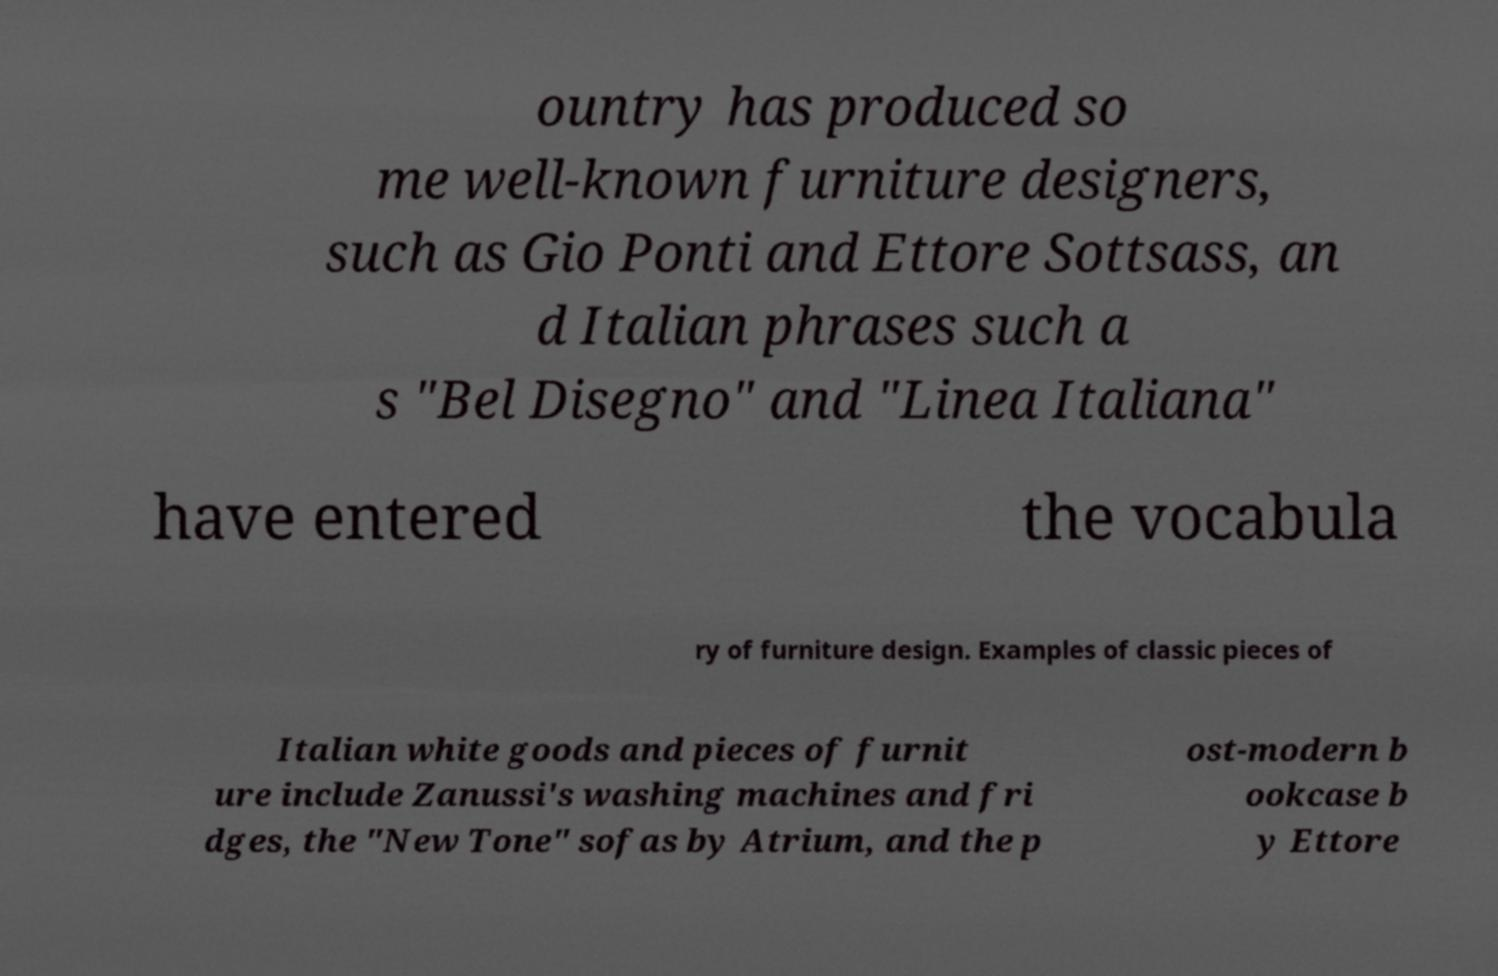There's text embedded in this image that I need extracted. Can you transcribe it verbatim? ountry has produced so me well-known furniture designers, such as Gio Ponti and Ettore Sottsass, an d Italian phrases such a s "Bel Disegno" and "Linea Italiana" have entered the vocabula ry of furniture design. Examples of classic pieces of Italian white goods and pieces of furnit ure include Zanussi's washing machines and fri dges, the "New Tone" sofas by Atrium, and the p ost-modern b ookcase b y Ettore 